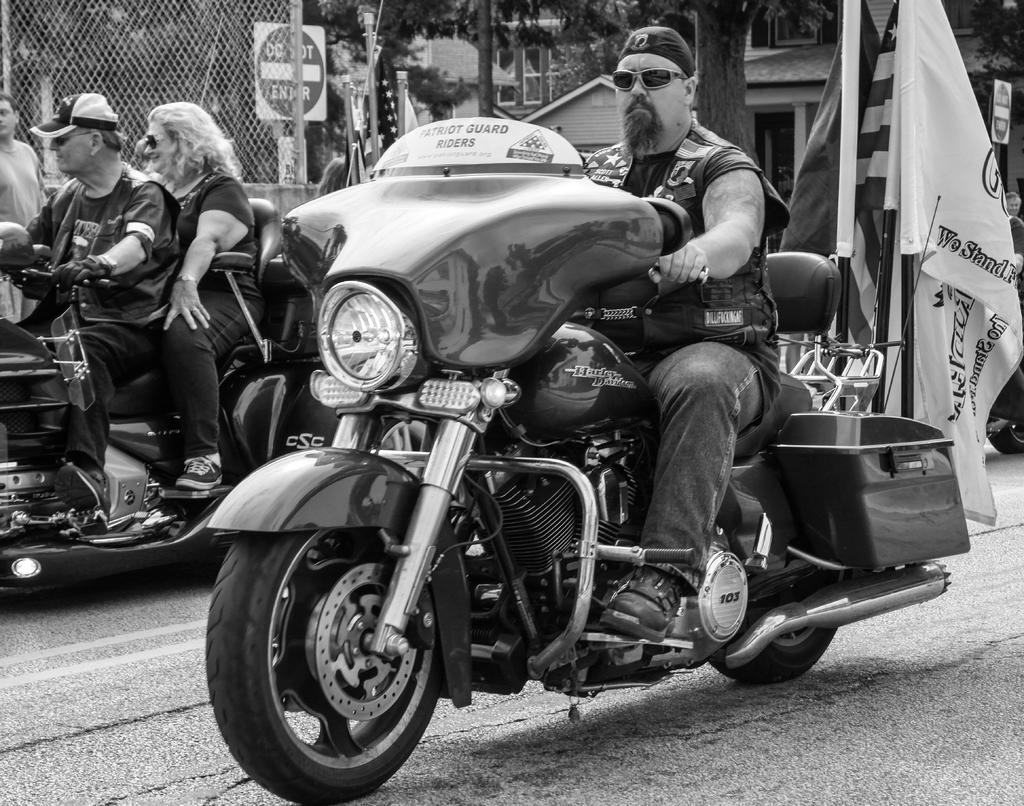What is the main subject of the image? The main subject of the image is a man riding a motorcycle. Who else is present on the motorcycle? There is a woman on the motorcycle. What can be seen in the background of the image? A flag is visible behind the people on the motorcycle. What architectural feature is present on the side of the image? There is a metal fence on the side of the image. What type of acoustics can be heard from the motorcycle in the image? The image does not provide any information about the acoustics of the motorcycle, so it cannot be determined from the image. 